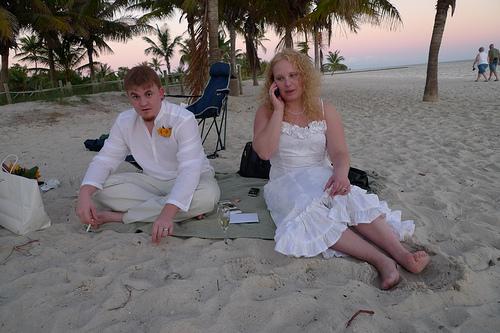Where is the camera sitting?
Write a very short answer. On beach. What color is the dress?
Quick response, please. White. What is the most likely relationship between these people?
Keep it brief. Married. How many people are sitting on the beach?
Short answer required. 2. What color skirt is the girl wearing?
Concise answer only. White. Is that a typical bench?
Answer briefly. No. What is the woman holding in her right hand?
Write a very short answer. Phone. Do these people enjoy nature?
Keep it brief. Yes. 